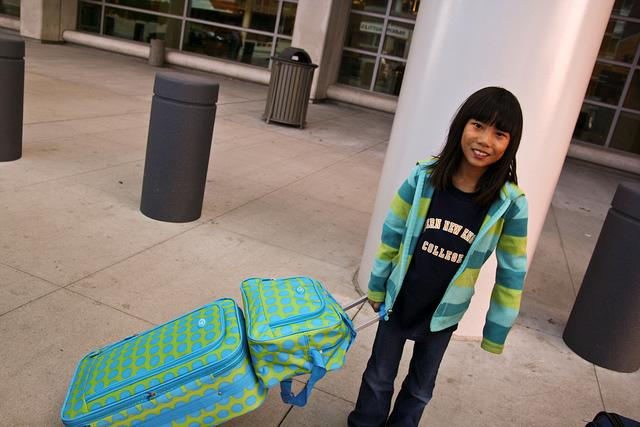Upon which vessel might this person go for a ride soon? Please explain your reasoning. airplane. She is dragging luggage. luggage is used to go on long trips through the air. 